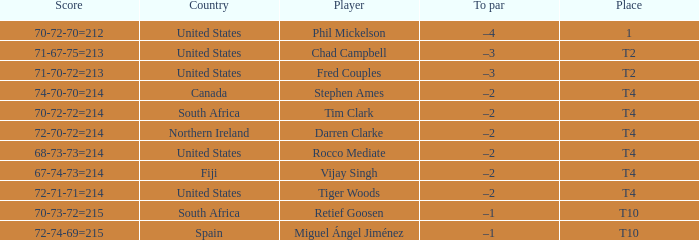What was the score for Spain? 72-74-69=215. 